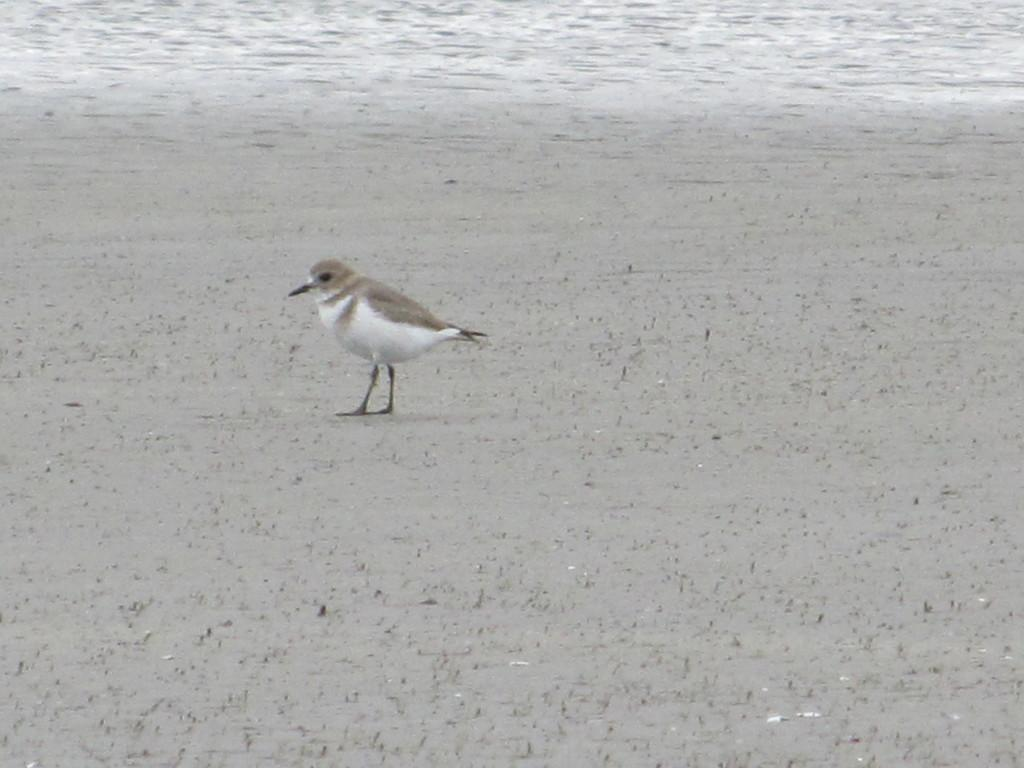What is the main setting or location depicted in the image? There is an open ground in the image. Can you describe any living creatures present in the image? There is a white and grey color bird in the image. Where is the bird located in the image? The bird is standing on the open ground. What type of lace can be seen hanging from the bird's beak in the image? There is no lace present in the image, nor is there any lace hanging from the bird's beak. 